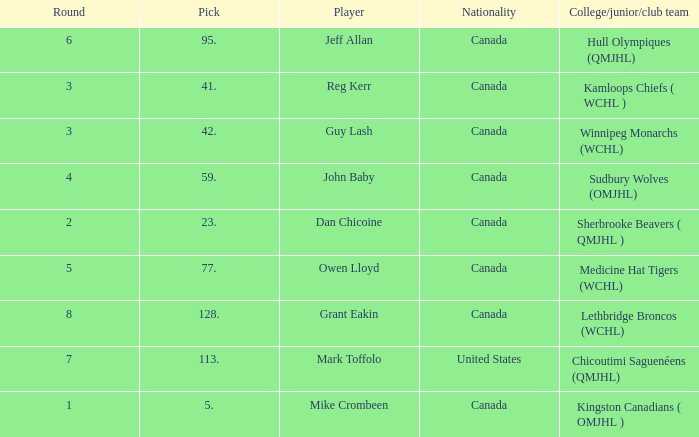Can you parse all the data within this table? {'header': ['Round', 'Pick', 'Player', 'Nationality', 'College/junior/club team'], 'rows': [['6', '95.', 'Jeff Allan', 'Canada', 'Hull Olympiques (QMJHL)'], ['3', '41.', 'Reg Kerr', 'Canada', 'Kamloops Chiefs ( WCHL )'], ['3', '42.', 'Guy Lash', 'Canada', 'Winnipeg Monarchs (WCHL)'], ['4', '59.', 'John Baby', 'Canada', 'Sudbury Wolves (OMJHL)'], ['2', '23.', 'Dan Chicoine', 'Canada', 'Sherbrooke Beavers ( QMJHL )'], ['5', '77.', 'Owen Lloyd', 'Canada', 'Medicine Hat Tigers (WCHL)'], ['8', '128.', 'Grant Eakin', 'Canada', 'Lethbridge Broncos (WCHL)'], ['7', '113.', 'Mark Toffolo', 'United States', 'Chicoutimi Saguenéens (QMJHL)'], ['1', '5.', 'Mike Crombeen', 'Canada', 'Kingston Canadians ( OMJHL )']]} Which Round has a Player of dan chicoine, and a Pick larger than 23? None. 